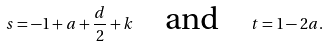<formula> <loc_0><loc_0><loc_500><loc_500>s = - 1 + a + \frac { d } { 2 } + k \quad \text {and} \quad t = 1 - 2 a .</formula> 